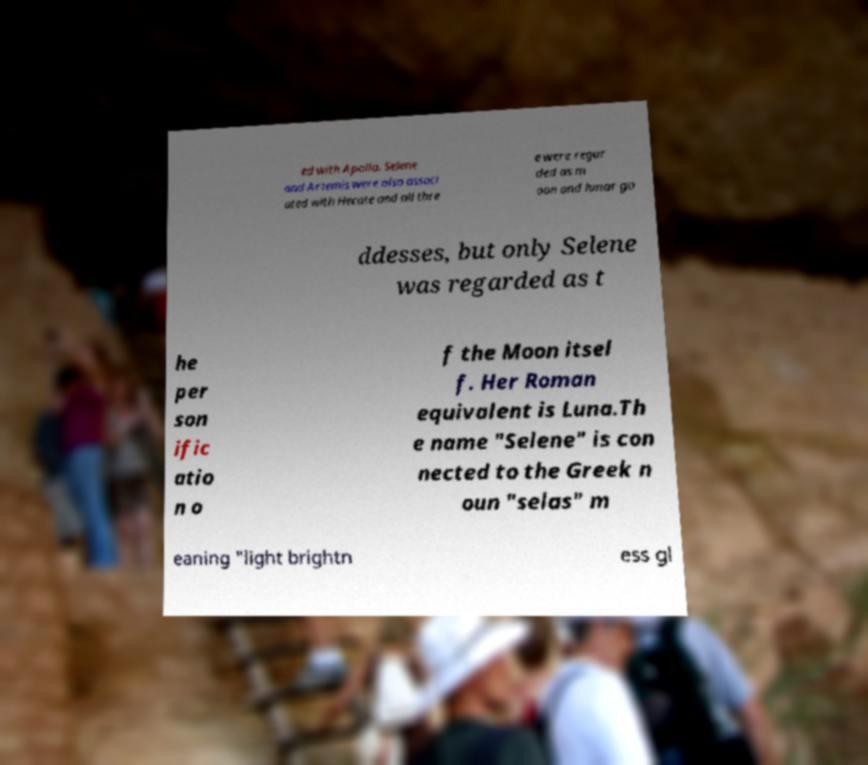Can you accurately transcribe the text from the provided image for me? ed with Apollo. Selene and Artemis were also associ ated with Hecate and all thre e were regar ded as m oon and lunar go ddesses, but only Selene was regarded as t he per son ific atio n o f the Moon itsel f. Her Roman equivalent is Luna.Th e name "Selene" is con nected to the Greek n oun "selas" m eaning "light brightn ess gl 